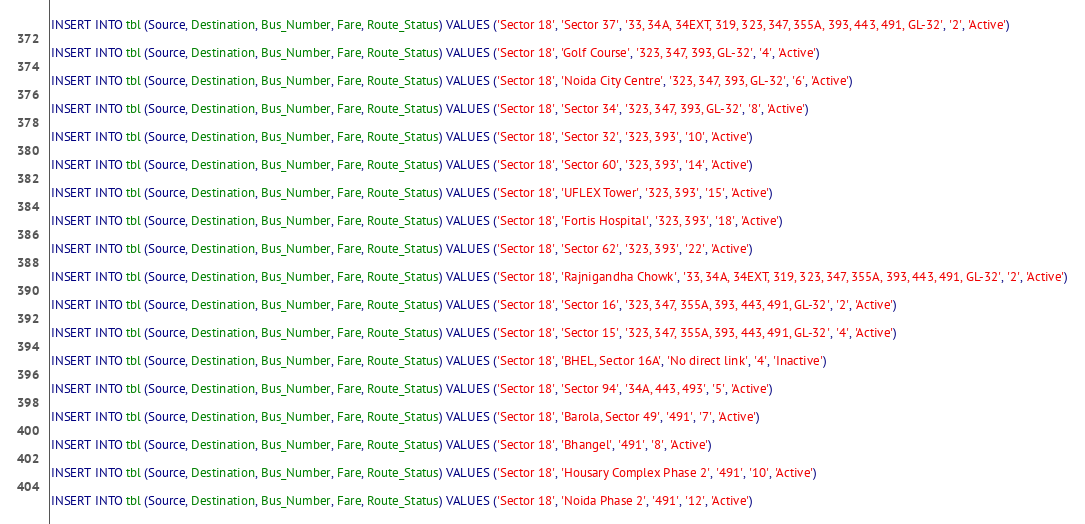Convert code to text. <code><loc_0><loc_0><loc_500><loc_500><_SQL_>
INSERT INTO tbl (Source, Destination, Bus_Number, Fare, Route_Status) VALUES ('Sector 18', 'Sector 37', '33, 34A, 34EXT, 319, 323, 347, 355A, 393, 443, 491, GL-32', '2', 'Active')

INSERT INTO tbl (Source, Destination, Bus_Number, Fare, Route_Status) VALUES ('Sector 18', 'Golf Course', '323, 347, 393, GL-32', '4', 'Active')

INSERT INTO tbl (Source, Destination, Bus_Number, Fare, Route_Status) VALUES ('Sector 18', 'Noida City Centre', '323, 347, 393, GL-32', '6', 'Active')

INSERT INTO tbl (Source, Destination, Bus_Number, Fare, Route_Status) VALUES ('Sector 18', 'Sector 34', '323, 347, 393, GL-32', '8', 'Active')

INSERT INTO tbl (Source, Destination, Bus_Number, Fare, Route_Status) VALUES ('Sector 18', 'Sector 32', '323, 393', '10', 'Active')

INSERT INTO tbl (Source, Destination, Bus_Number, Fare, Route_Status) VALUES ('Sector 18', 'Sector 60', '323, 393', '14', 'Active')

INSERT INTO tbl (Source, Destination, Bus_Number, Fare, Route_Status) VALUES ('Sector 18', 'UFLEX Tower', '323, 393', '15', 'Active')

INSERT INTO tbl (Source, Destination, Bus_Number, Fare, Route_Status) VALUES ('Sector 18', 'Fortis Hospital', '323, 393', '18', 'Active')

INSERT INTO tbl (Source, Destination, Bus_Number, Fare, Route_Status) VALUES ('Sector 18', 'Sector 62', '323, 393', '22', 'Active')

INSERT INTO tbl (Source, Destination, Bus_Number, Fare, Route_Status) VALUES ('Sector 18', 'Rajnigandha Chowk', '33, 34A, 34EXT, 319, 323, 347, 355A, 393, 443, 491, GL-32', '2', 'Active')

INSERT INTO tbl (Source, Destination, Bus_Number, Fare, Route_Status) VALUES ('Sector 18', 'Sector 16', '323, 347, 355A, 393, 443, 491, GL-32', '2', 'Active')

INSERT INTO tbl (Source, Destination, Bus_Number, Fare, Route_Status) VALUES ('Sector 18', 'Sector 15', '323, 347, 355A, 393, 443, 491, GL-32', '4', 'Active')

INSERT INTO tbl (Source, Destination, Bus_Number, Fare, Route_Status) VALUES ('Sector 18', 'BHEL, Sector 16A', 'No direct link', '4', 'Inactive')

INSERT INTO tbl (Source, Destination, Bus_Number, Fare, Route_Status) VALUES ('Sector 18', 'Sector 94', '34A, 443, 493', '5', 'Active')

INSERT INTO tbl (Source, Destination, Bus_Number, Fare, Route_Status) VALUES ('Sector 18', 'Barola, Sector 49', '491', '7', 'Active')

INSERT INTO tbl (Source, Destination, Bus_Number, Fare, Route_Status) VALUES ('Sector 18', 'Bhangel', '491', '8', 'Active')

INSERT INTO tbl (Source, Destination, Bus_Number, Fare, Route_Status) VALUES ('Sector 18', 'Housary Complex Phase 2', '491', '10', 'Active')

INSERT INTO tbl (Source, Destination, Bus_Number, Fare, Route_Status) VALUES ('Sector 18', 'Noida Phase 2', '491', '12', 'Active')
</code> 